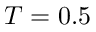<formula> <loc_0><loc_0><loc_500><loc_500>T = 0 . 5</formula> 